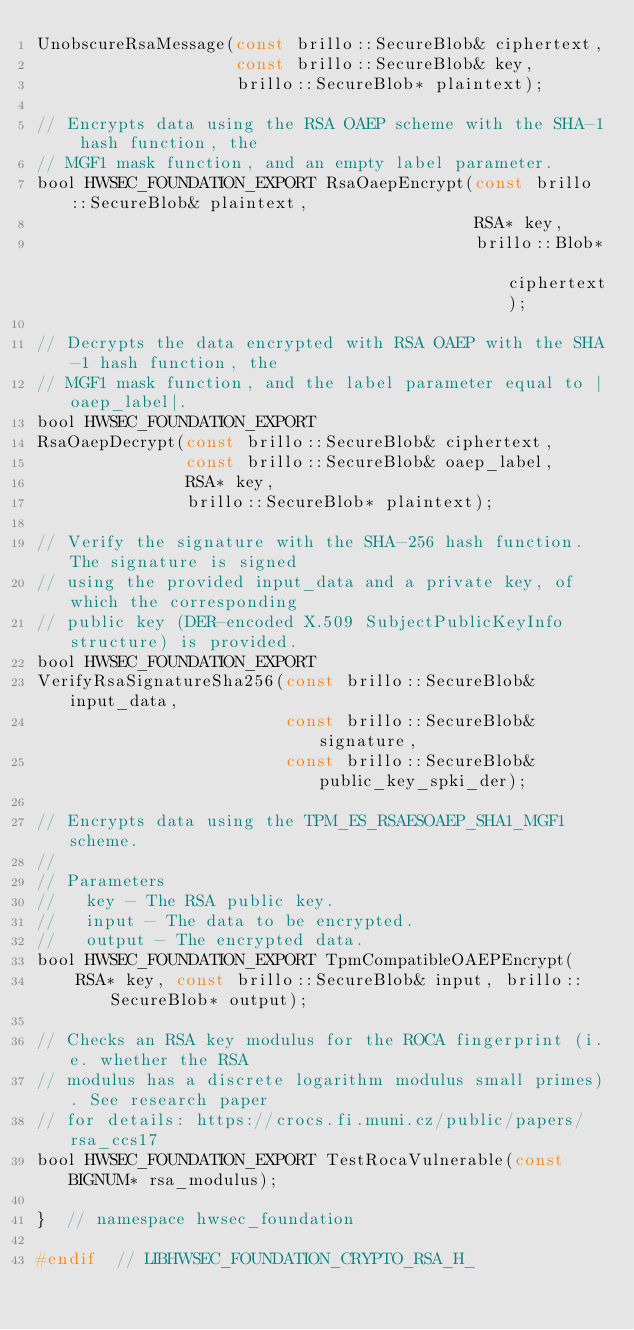Convert code to text. <code><loc_0><loc_0><loc_500><loc_500><_C_>UnobscureRsaMessage(const brillo::SecureBlob& ciphertext,
                    const brillo::SecureBlob& key,
                    brillo::SecureBlob* plaintext);

// Encrypts data using the RSA OAEP scheme with the SHA-1 hash function, the
// MGF1 mask function, and an empty label parameter.
bool HWSEC_FOUNDATION_EXPORT RsaOaepEncrypt(const brillo::SecureBlob& plaintext,
                                            RSA* key,
                                            brillo::Blob* ciphertext);

// Decrypts the data encrypted with RSA OAEP with the SHA-1 hash function, the
// MGF1 mask function, and the label parameter equal to |oaep_label|.
bool HWSEC_FOUNDATION_EXPORT
RsaOaepDecrypt(const brillo::SecureBlob& ciphertext,
               const brillo::SecureBlob& oaep_label,
               RSA* key,
               brillo::SecureBlob* plaintext);

// Verify the signature with the SHA-256 hash function. The signature is signed
// using the provided input_data and a private key, of which the corresponding
// public key (DER-encoded X.509 SubjectPublicKeyInfo structure) is provided.
bool HWSEC_FOUNDATION_EXPORT
VerifyRsaSignatureSha256(const brillo::SecureBlob& input_data,
                         const brillo::SecureBlob& signature,
                         const brillo::SecureBlob& public_key_spki_der);

// Encrypts data using the TPM_ES_RSAESOAEP_SHA1_MGF1 scheme.
//
// Parameters
//   key - The RSA public key.
//   input - The data to be encrypted.
//   output - The encrypted data.
bool HWSEC_FOUNDATION_EXPORT TpmCompatibleOAEPEncrypt(
    RSA* key, const brillo::SecureBlob& input, brillo::SecureBlob* output);

// Checks an RSA key modulus for the ROCA fingerprint (i.e. whether the RSA
// modulus has a discrete logarithm modulus small primes). See research paper
// for details: https://crocs.fi.muni.cz/public/papers/rsa_ccs17
bool HWSEC_FOUNDATION_EXPORT TestRocaVulnerable(const BIGNUM* rsa_modulus);

}  // namespace hwsec_foundation

#endif  // LIBHWSEC_FOUNDATION_CRYPTO_RSA_H_
</code> 